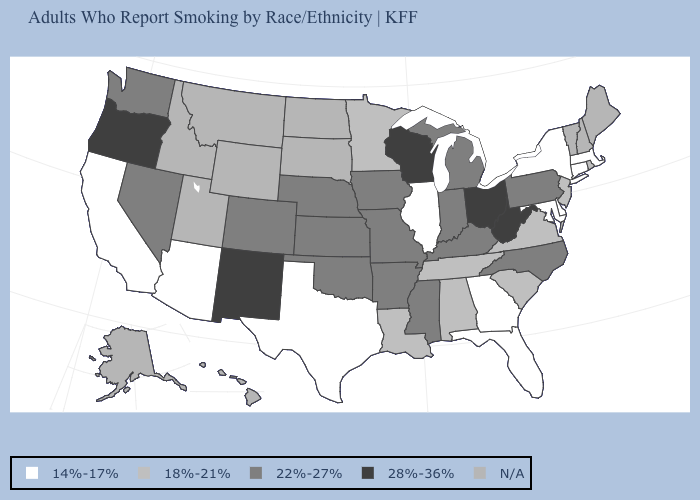What is the value of Pennsylvania?
Answer briefly. 22%-27%. What is the highest value in the USA?
Answer briefly. 28%-36%. Is the legend a continuous bar?
Short answer required. No. What is the value of Texas?
Give a very brief answer. 14%-17%. Name the states that have a value in the range N/A?
Answer briefly. Alaska, Hawaii, Idaho, Maine, Montana, New Hampshire, North Dakota, South Dakota, Utah, Vermont, Wyoming. Is the legend a continuous bar?
Give a very brief answer. No. Name the states that have a value in the range 14%-17%?
Keep it brief. Arizona, California, Connecticut, Delaware, Florida, Georgia, Illinois, Maryland, Massachusetts, New York, Texas. What is the lowest value in the USA?
Keep it brief. 14%-17%. What is the value of Idaho?
Keep it brief. N/A. Does California have the lowest value in the USA?
Write a very short answer. Yes. What is the value of Wisconsin?
Short answer required. 28%-36%. Name the states that have a value in the range 18%-21%?
Write a very short answer. Alabama, Louisiana, Minnesota, New Jersey, Rhode Island, South Carolina, Tennessee, Virginia. What is the lowest value in the USA?
Keep it brief. 14%-17%. 